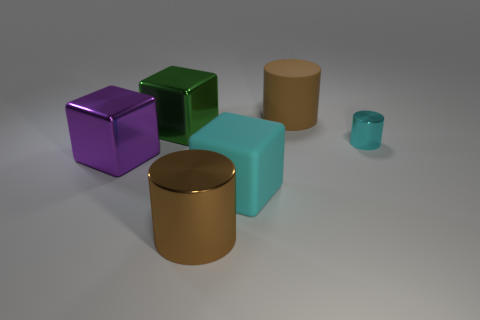Subtract all big cyan blocks. How many blocks are left? 2 Add 1 matte cylinders. How many objects exist? 7 Subtract all brown cylinders. How many cylinders are left? 1 Subtract all green spheres. How many brown cylinders are left? 2 Subtract 0 blue blocks. How many objects are left? 6 Subtract 3 cylinders. How many cylinders are left? 0 Subtract all green cylinders. Subtract all blue spheres. How many cylinders are left? 3 Subtract all cyan metallic things. Subtract all large purple metallic things. How many objects are left? 4 Add 2 objects. How many objects are left? 8 Add 6 large brown shiny objects. How many large brown shiny objects exist? 7 